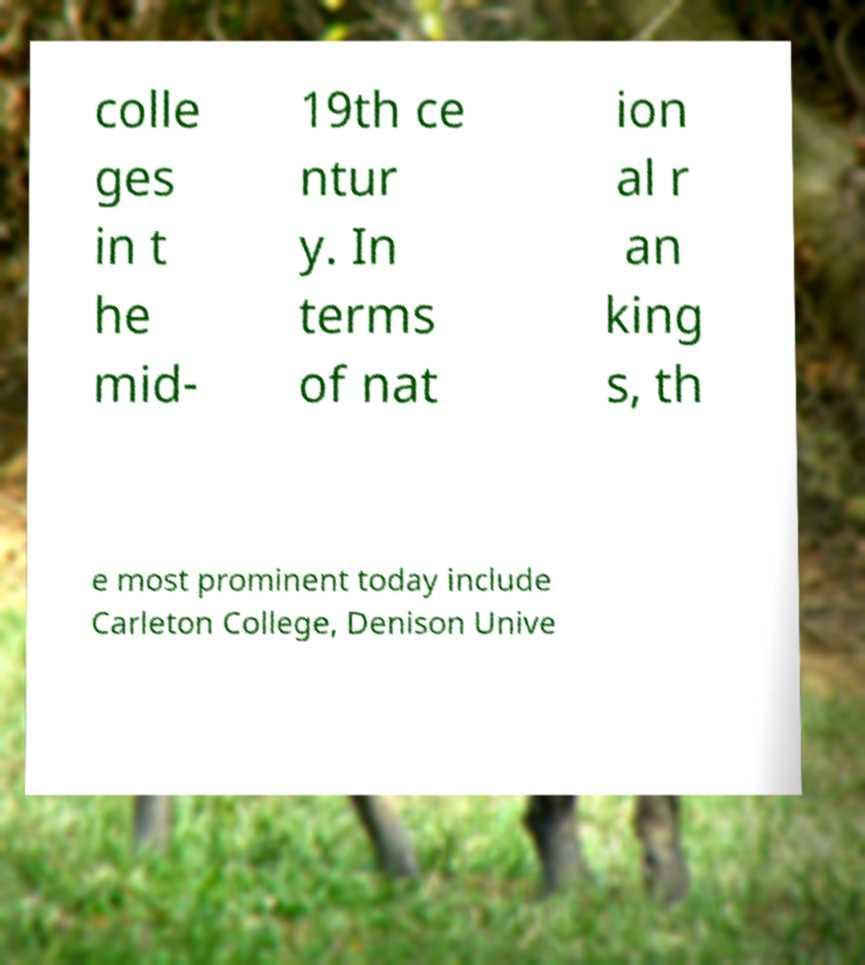For documentation purposes, I need the text within this image transcribed. Could you provide that? colle ges in t he mid- 19th ce ntur y. In terms of nat ion al r an king s, th e most prominent today include Carleton College, Denison Unive 